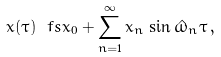<formula> <loc_0><loc_0><loc_500><loc_500>x ( \tau ) \ f s x _ { 0 } + \sum _ { n = 1 } ^ { \infty } x _ { n } \, \sin \hat { \omega } _ { n } \tau \, ,</formula> 